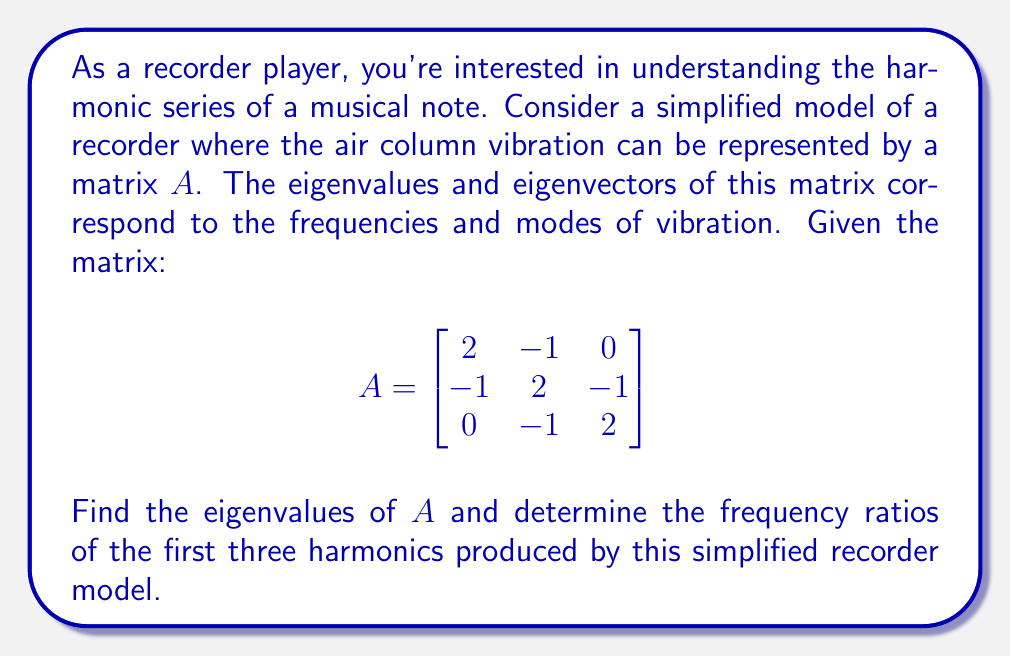Solve this math problem. To solve this problem, we'll follow these steps:

1) Find the characteristic equation of matrix $A$:
   $det(A - \lambda I) = 0$

2) Solve the characteristic equation to find the eigenvalues.

3) Interpret the eigenvalues as frequencies and calculate their ratios.

Step 1: Characteristic equation

$$det(A - \lambda I) = \begin{vmatrix}
2-\lambda & -1 & 0 \\
-1 & 2-\lambda & -1 \\
0 & -1 & 2-\lambda
\end{vmatrix} = 0$$

Expanding this determinant:

$$(2-\lambda)[(2-\lambda)(2-\lambda) - 1] - (-1)[-1(2-\lambda)] = 0$$
$$(2-\lambda)[4-4\lambda+\lambda^2 - 1] + (2-\lambda) = 0$$
$$(2-\lambda)(\lambda^2-4\lambda+3) + (2-\lambda) = 0$$
$$2\lambda^2-8\lambda+6-\lambda^3+4\lambda^2-3\lambda+2-\lambda = 0$$
$$-\lambda^3+6\lambda^2-12\lambda+8 = 0$$

Step 2: Solve the characteristic equation

The characteristic equation is:
$$\lambda^3-6\lambda^2+12\lambda-8 = 0$$

This can be factored as:
$$(\lambda-2)(\lambda-2)(\lambda-2) = 0$$

Therefore, the eigenvalue is $\lambda = 2$ with algebraic multiplicity 3.

Step 3: Interpret eigenvalues as frequencies

In this simplified model, the eigenvalues correspond to the frequencies of the harmonics. Since we have only one eigenvalue $\lambda = 2$, this represents the fundamental frequency.

In a real recorder, the harmonic series would typically follow the pattern 1:2:3 for the first three harmonics. However, in our simplified model, we only have one frequency represented.

To relate this to a real recorder, we can consider that this model captures only the fundamental frequency, and the higher harmonics would need a more complex model to represent.
Answer: The eigenvalue of the matrix $A$ is $\lambda = 2$ with algebraic multiplicity 3. In this simplified model, this single eigenvalue represents the fundamental frequency of the recorder. The model does not provide information about higher harmonics, so we cannot calculate frequency ratios for the first three harmonics based solely on this information. 